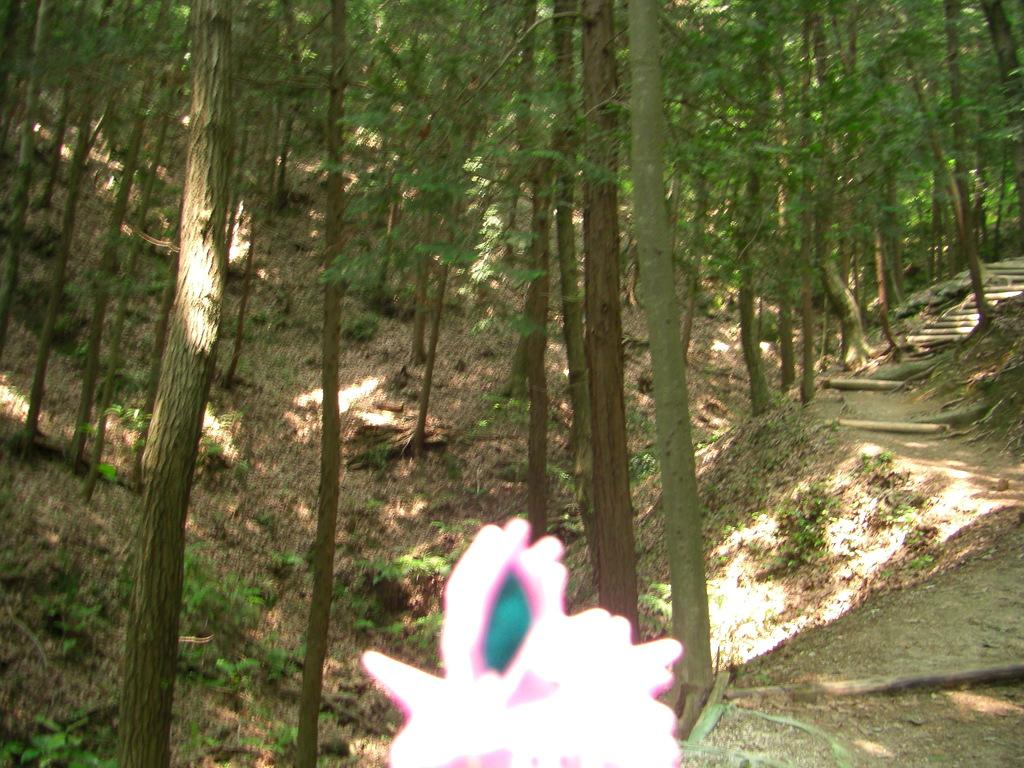What type of vegetation is present on the land in the image? There are plants on the land in the image. What other type of vegetation can be seen in the image? There are trees in the image. Can you describe the object at the bottom of the image? Unfortunately, the facts provided do not give any information about the object at the bottom of the image. What decision was made by the group of people in the image? There are no people present in the image, so it is impossible to determine if a decision was made by a group. What type of fuel is being used by the vehicle in the image? There is no vehicle present in the image, so it is impossible to determine the type of fuel being used. 